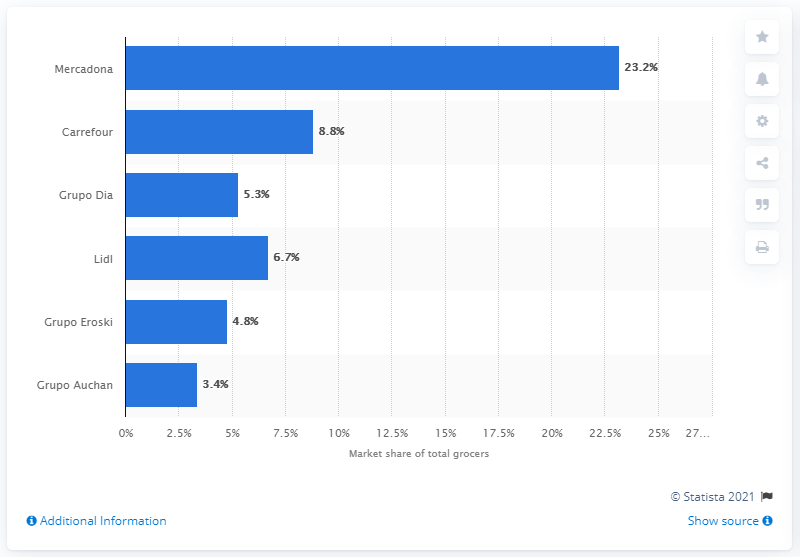Identify some key points in this picture. According to data from the 12 weeks leading up to January 3rd, 2020, Carrefour was the second largest player in the grocery retail market in Spain. 